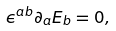<formula> <loc_0><loc_0><loc_500><loc_500>\epsilon ^ { a b } \partial _ { a } E _ { b } = 0 ,</formula> 